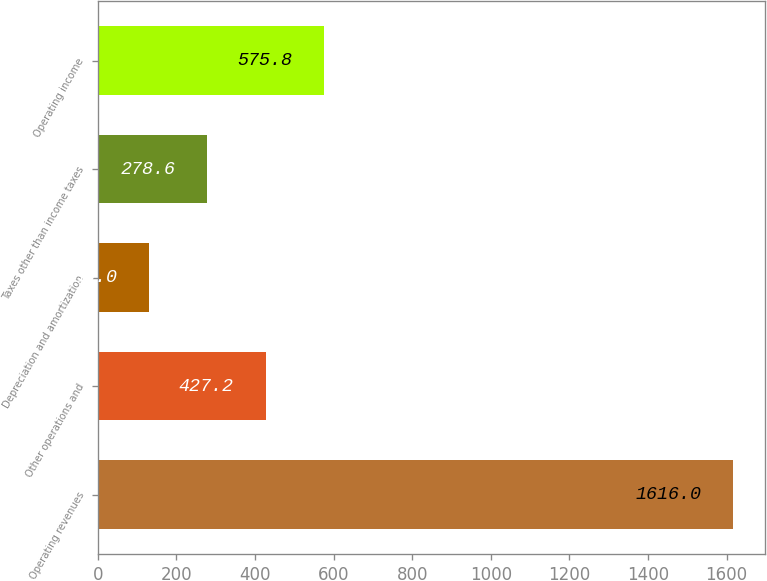Convert chart. <chart><loc_0><loc_0><loc_500><loc_500><bar_chart><fcel>Operating revenues<fcel>Other operations and<fcel>Depreciation and amortization<fcel>Taxes other than income taxes<fcel>Operating income<nl><fcel>1616<fcel>427.2<fcel>130<fcel>278.6<fcel>575.8<nl></chart> 